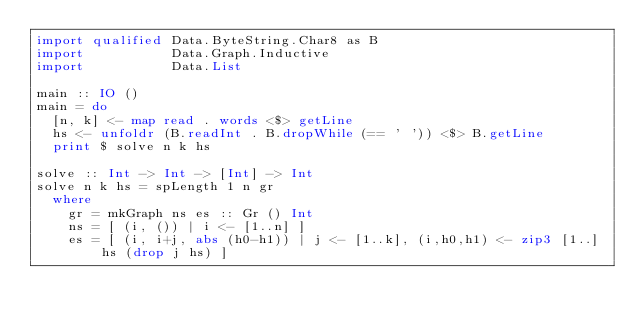<code> <loc_0><loc_0><loc_500><loc_500><_Haskell_>import qualified Data.ByteString.Char8 as B
import           Data.Graph.Inductive
import           Data.List

main :: IO ()
main = do
  [n, k] <- map read . words <$> getLine
  hs <- unfoldr (B.readInt . B.dropWhile (== ' ')) <$> B.getLine
  print $ solve n k hs

solve :: Int -> Int -> [Int] -> Int
solve n k hs = spLength 1 n gr
  where
    gr = mkGraph ns es :: Gr () Int
    ns = [ (i, ()) | i <- [1..n] ]
    es = [ (i, i+j, abs (h0-h1)) | j <- [1..k], (i,h0,h1) <- zip3 [1..] hs (drop j hs) ]
</code> 